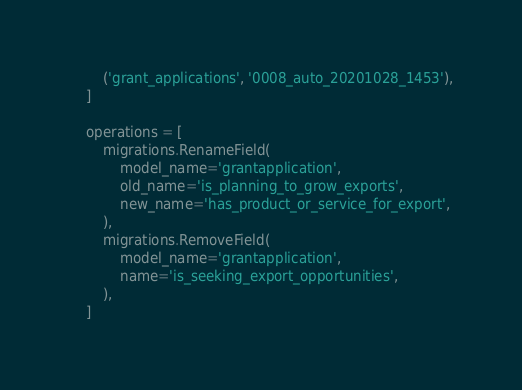<code> <loc_0><loc_0><loc_500><loc_500><_Python_>        ('grant_applications', '0008_auto_20201028_1453'),
    ]

    operations = [
        migrations.RenameField(
            model_name='grantapplication',
            old_name='is_planning_to_grow_exports',
            new_name='has_product_or_service_for_export',
        ),
        migrations.RemoveField(
            model_name='grantapplication',
            name='is_seeking_export_opportunities',
        ),
    ]
</code> 